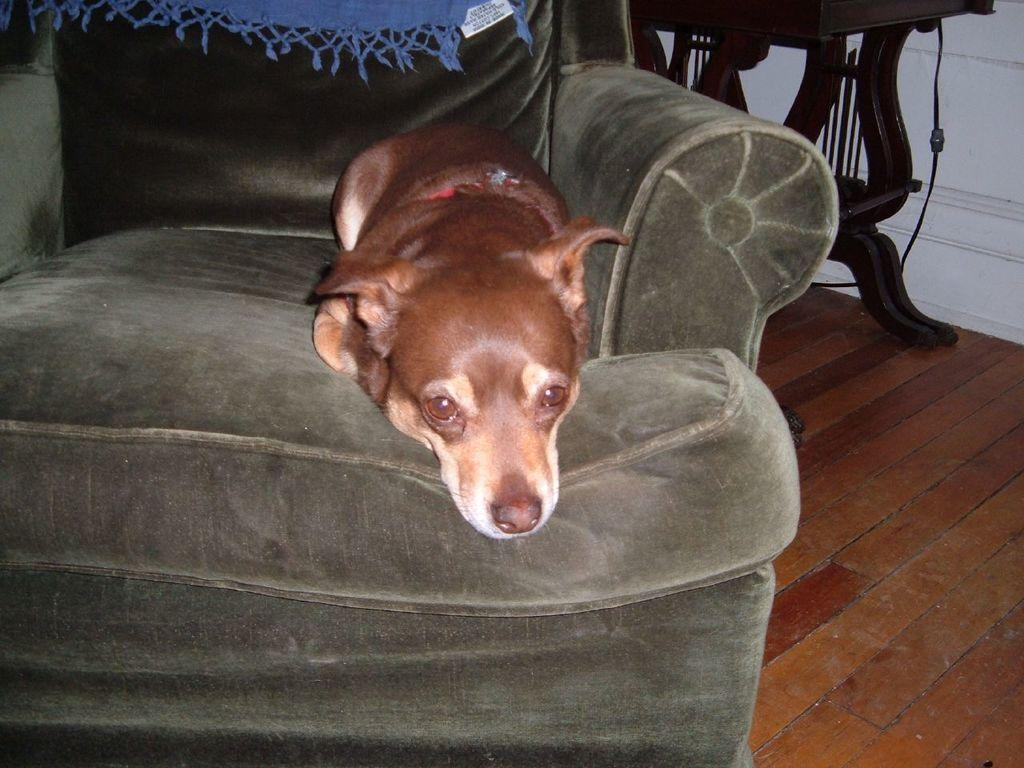What type of animal can be seen in the picture? There is a dog in the picture. What is the dog doing in the picture? The dog is sleeping. Where is the dog located in the image? The dog is on a sofa. Can you describe the position of the sofa in the image? The sofa is in the middle of the image. What flavor of ice cream does the dog prefer in the image? There is no ice cream present in the image, and therefore no preference can be determined. 